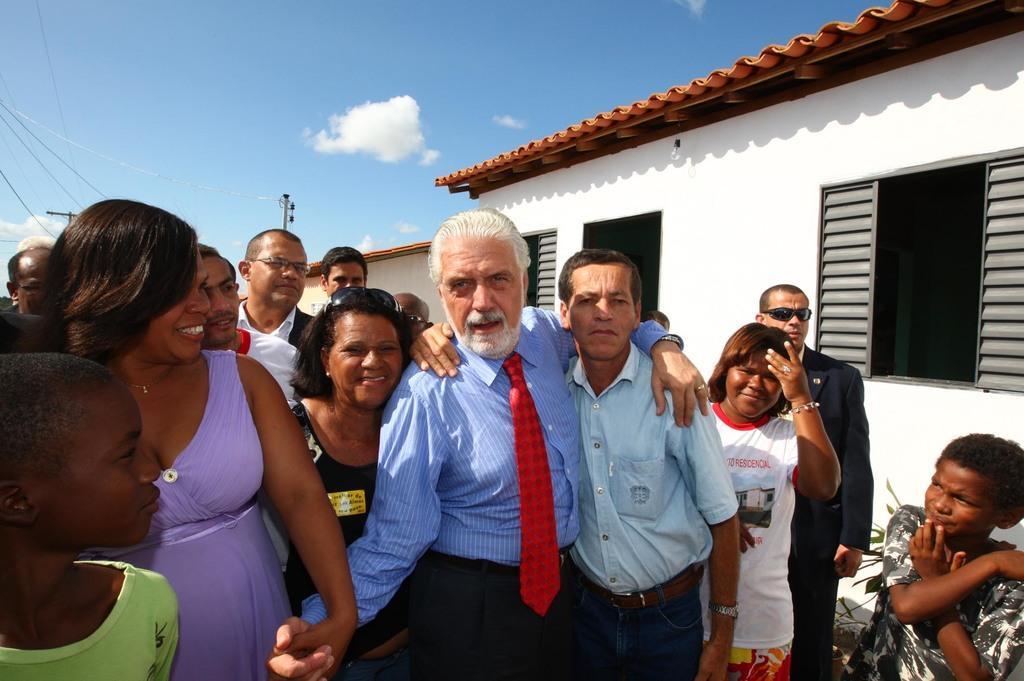Can you describe this image briefly? This is the picture of a place where we have some people standing in front of the house to which there are some windows and behind there two poles and some clouds to the sky. 